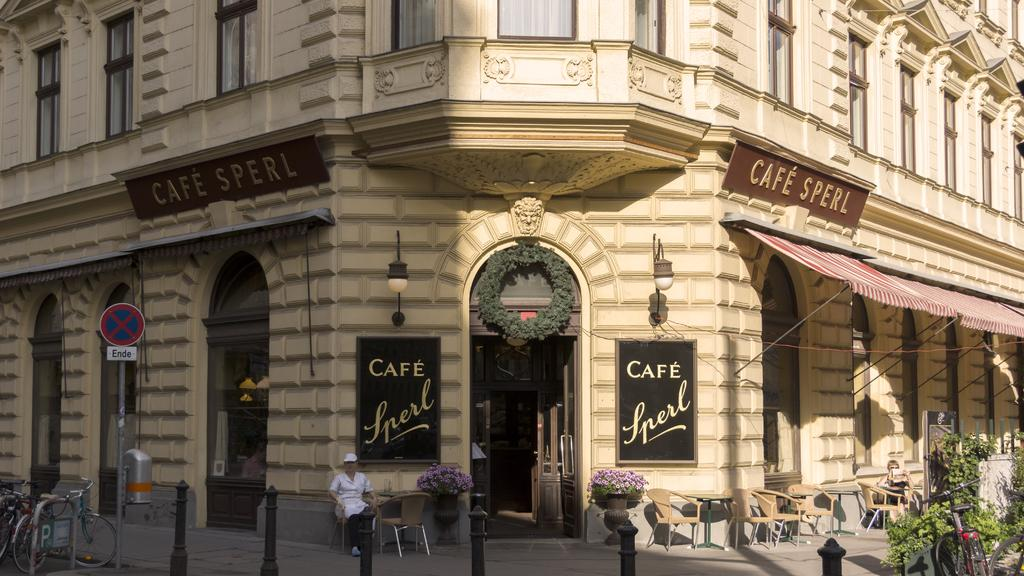What type of structure is visible in the image? There is a building in the image. What objects are present in the image that might be used for displaying information or advertisements? There are boards in the image. What features of the building are visible in the image? There are doors and lights visible in the image. What type of furniture is present in the image? There are chairs in the image. What type of vegetation is present in the image? There are plants and flowers in the image. What mode of transportation is present in the image? There are bicycles in the image. What other object is present in the image that might be used for hanging signs or decorations? There is a pole in the image. What are the two persons in the image doing? Two persons are sitting on chairs in the image. What type of pencil can be seen in the image? There is no pencil present in the image. How does the nation react to the rainstorm in the image? There is no rainstorm present in the image, so it is not possible to determine how the nation might react. 